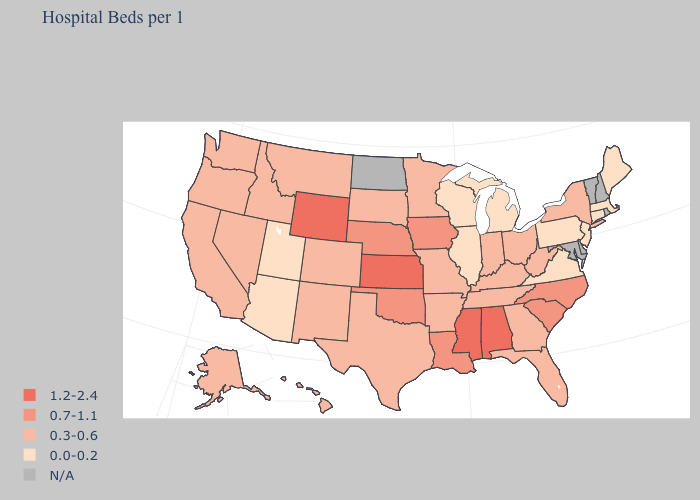Which states have the lowest value in the Northeast?
Give a very brief answer. Connecticut, Maine, Massachusetts, New Jersey, Pennsylvania. What is the value of Illinois?
Keep it brief. 0.0-0.2. Name the states that have a value in the range N/A?
Quick response, please. Delaware, Maryland, New Hampshire, North Dakota, Rhode Island, Vermont. Which states hav the highest value in the MidWest?
Concise answer only. Kansas. Name the states that have a value in the range 1.2-2.4?
Quick response, please. Alabama, Kansas, Mississippi, Wyoming. What is the value of Texas?
Keep it brief. 0.3-0.6. How many symbols are there in the legend?
Answer briefly. 5. Which states have the lowest value in the West?
Write a very short answer. Arizona, Utah. What is the lowest value in the Northeast?
Quick response, please. 0.0-0.2. What is the value of Hawaii?
Be succinct. 0.3-0.6. What is the value of Connecticut?
Concise answer only. 0.0-0.2. What is the highest value in states that border New Jersey?
Keep it brief. 0.3-0.6. 